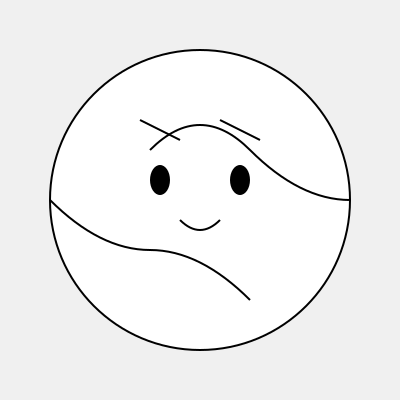This stylized portrait represents a famous Filipino literary figure known for his novels that critiqued Spanish colonial rule. Who is this author? 1. The portrait shows a stylized face with distinctive features:
   - Curly hair represented by curved lines at the top
   - Large, expressive eyes
   - A mustache indicated by the curved line below the nose

2. These features are characteristic of Jose Rizal, a prominent Filipino author and national hero.

3. Jose Rizal is famous for his novels that criticized Spanish colonial rule in the Philippines:
   - "Noli Me Tángere" (Touch Me Not)
   - "El Filibusterismo" (The Filibuster)

4. Rizal's works were instrumental in sparking the Philippine Revolution against Spanish colonial rule.

5. His writings often focused on themes of social injustice, colonial oppression, and the need for reform in Philippine society.

6. The stylized nature of the portrait aligns with modern artistic interpretations of historical figures, which is common in contemporary Philippine cultural representations.

Given these clues and the context of Philippine literature, the portrait most likely represents Jose Rizal.
Answer: Jose Rizal 